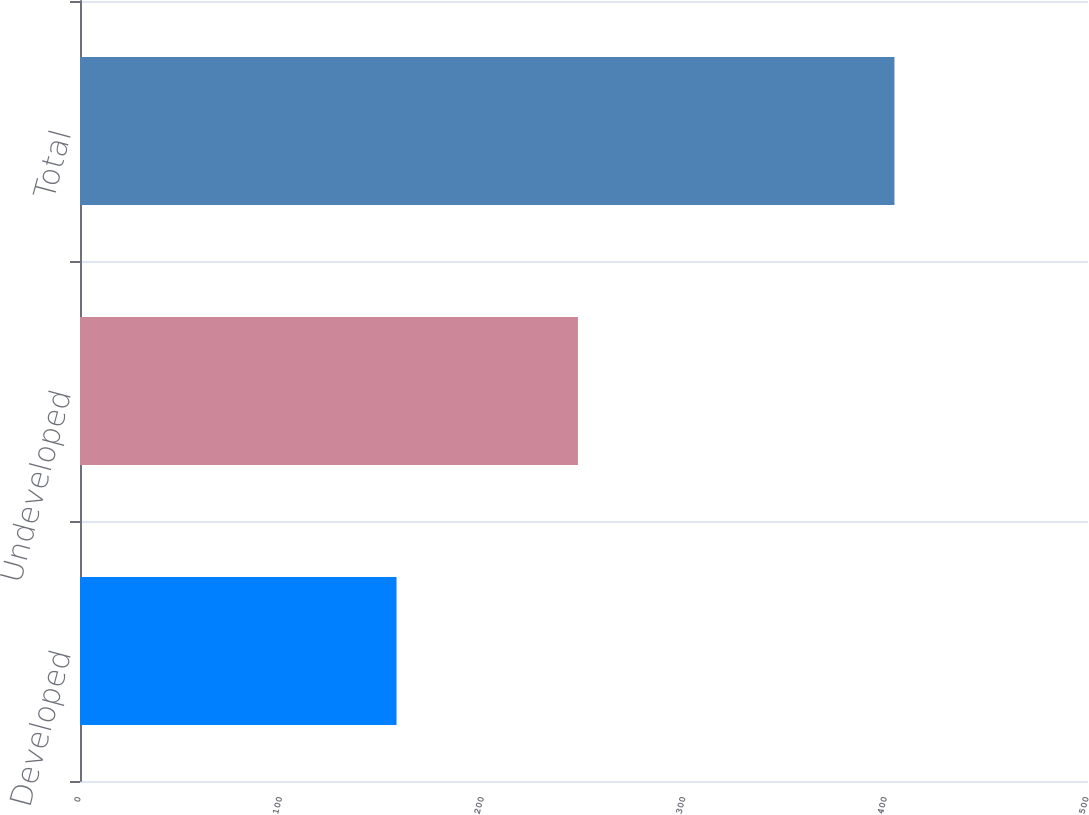<chart> <loc_0><loc_0><loc_500><loc_500><bar_chart><fcel>Developed<fcel>Undeveloped<fcel>Total<nl><fcel>157<fcel>247<fcel>404<nl></chart> 